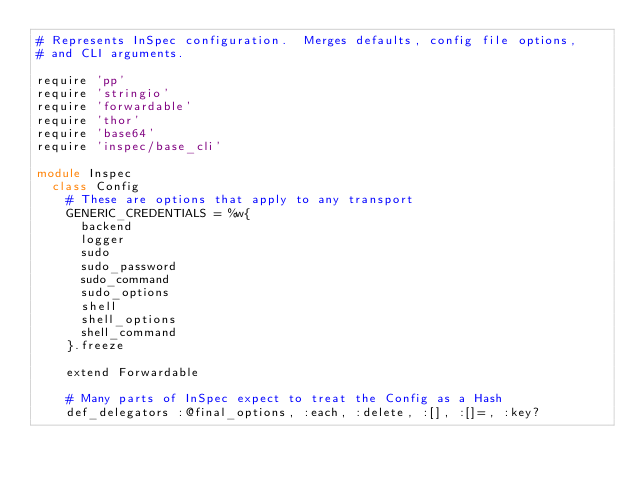Convert code to text. <code><loc_0><loc_0><loc_500><loc_500><_Ruby_># Represents InSpec configuration.  Merges defaults, config file options,
# and CLI arguments.

require 'pp'
require 'stringio'
require 'forwardable'
require 'thor'
require 'base64'
require 'inspec/base_cli'

module Inspec
  class Config
    # These are options that apply to any transport
    GENERIC_CREDENTIALS = %w{
      backend
      logger
      sudo
      sudo_password
      sudo_command
      sudo_options
      shell
      shell_options
      shell_command
    }.freeze

    extend Forwardable

    # Many parts of InSpec expect to treat the Config as a Hash
    def_delegators :@final_options, :each, :delete, :[], :[]=, :key?</code> 